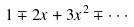<formula> <loc_0><loc_0><loc_500><loc_500>1 \mp 2 x + 3 x ^ { 2 } \mp \cdot \cdot \cdot</formula> 